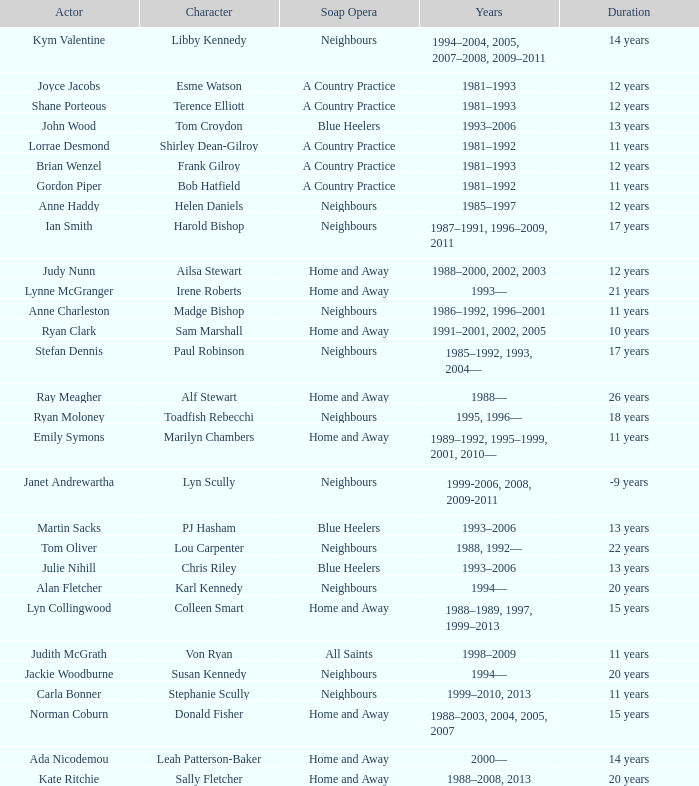Which actor played on Home and Away for 20 years? Kate Ritchie. 